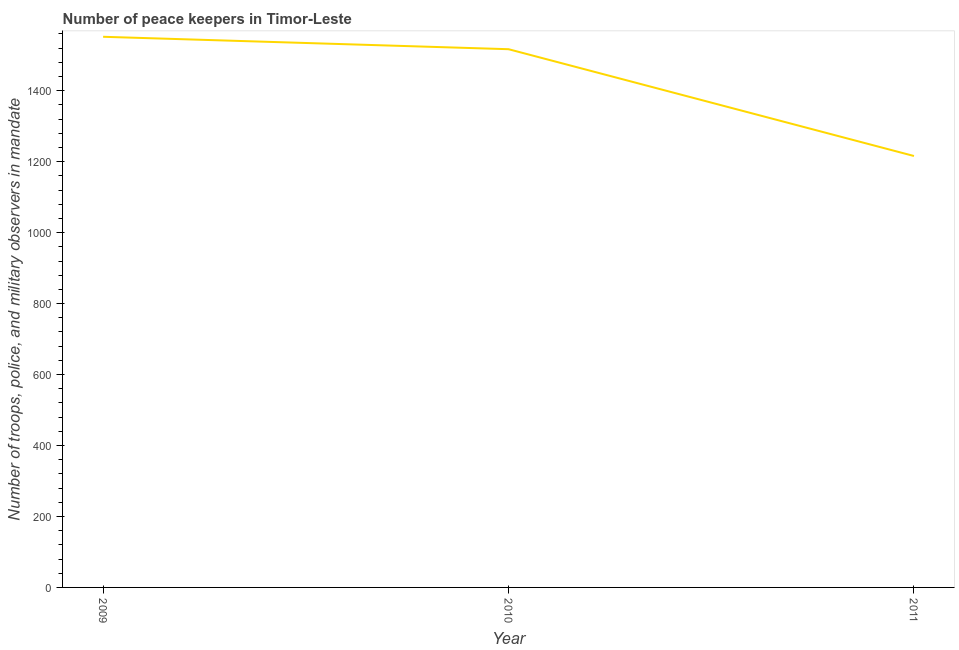What is the number of peace keepers in 2010?
Provide a succinct answer. 1517. Across all years, what is the maximum number of peace keepers?
Ensure brevity in your answer.  1552. Across all years, what is the minimum number of peace keepers?
Your response must be concise. 1216. In which year was the number of peace keepers maximum?
Ensure brevity in your answer.  2009. What is the sum of the number of peace keepers?
Offer a very short reply. 4285. What is the difference between the number of peace keepers in 2009 and 2010?
Provide a succinct answer. 35. What is the average number of peace keepers per year?
Your answer should be very brief. 1428.33. What is the median number of peace keepers?
Your answer should be compact. 1517. In how many years, is the number of peace keepers greater than 1480 ?
Make the answer very short. 2. What is the ratio of the number of peace keepers in 2010 to that in 2011?
Your answer should be very brief. 1.25. Is the number of peace keepers in 2009 less than that in 2011?
Your answer should be compact. No. Is the sum of the number of peace keepers in 2009 and 2010 greater than the maximum number of peace keepers across all years?
Keep it short and to the point. Yes. What is the difference between the highest and the lowest number of peace keepers?
Offer a terse response. 336. In how many years, is the number of peace keepers greater than the average number of peace keepers taken over all years?
Provide a succinct answer. 2. How many lines are there?
Your answer should be compact. 1. What is the difference between two consecutive major ticks on the Y-axis?
Keep it short and to the point. 200. Are the values on the major ticks of Y-axis written in scientific E-notation?
Offer a very short reply. No. Does the graph contain grids?
Make the answer very short. No. What is the title of the graph?
Provide a succinct answer. Number of peace keepers in Timor-Leste. What is the label or title of the X-axis?
Your answer should be very brief. Year. What is the label or title of the Y-axis?
Your response must be concise. Number of troops, police, and military observers in mandate. What is the Number of troops, police, and military observers in mandate in 2009?
Your answer should be compact. 1552. What is the Number of troops, police, and military observers in mandate of 2010?
Your answer should be compact. 1517. What is the Number of troops, police, and military observers in mandate of 2011?
Ensure brevity in your answer.  1216. What is the difference between the Number of troops, police, and military observers in mandate in 2009 and 2010?
Your response must be concise. 35. What is the difference between the Number of troops, police, and military observers in mandate in 2009 and 2011?
Your response must be concise. 336. What is the difference between the Number of troops, police, and military observers in mandate in 2010 and 2011?
Keep it short and to the point. 301. What is the ratio of the Number of troops, police, and military observers in mandate in 2009 to that in 2011?
Your answer should be very brief. 1.28. What is the ratio of the Number of troops, police, and military observers in mandate in 2010 to that in 2011?
Provide a short and direct response. 1.25. 